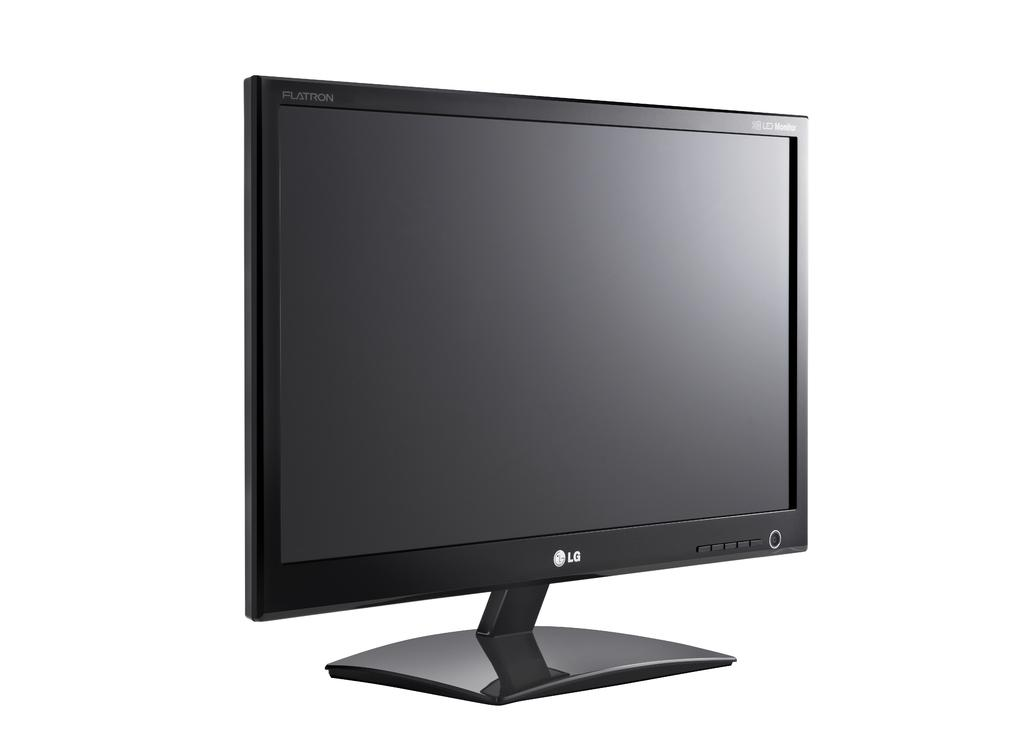Provide a one-sentence caption for the provided image. an LG computer monitor with a flatron screen. 